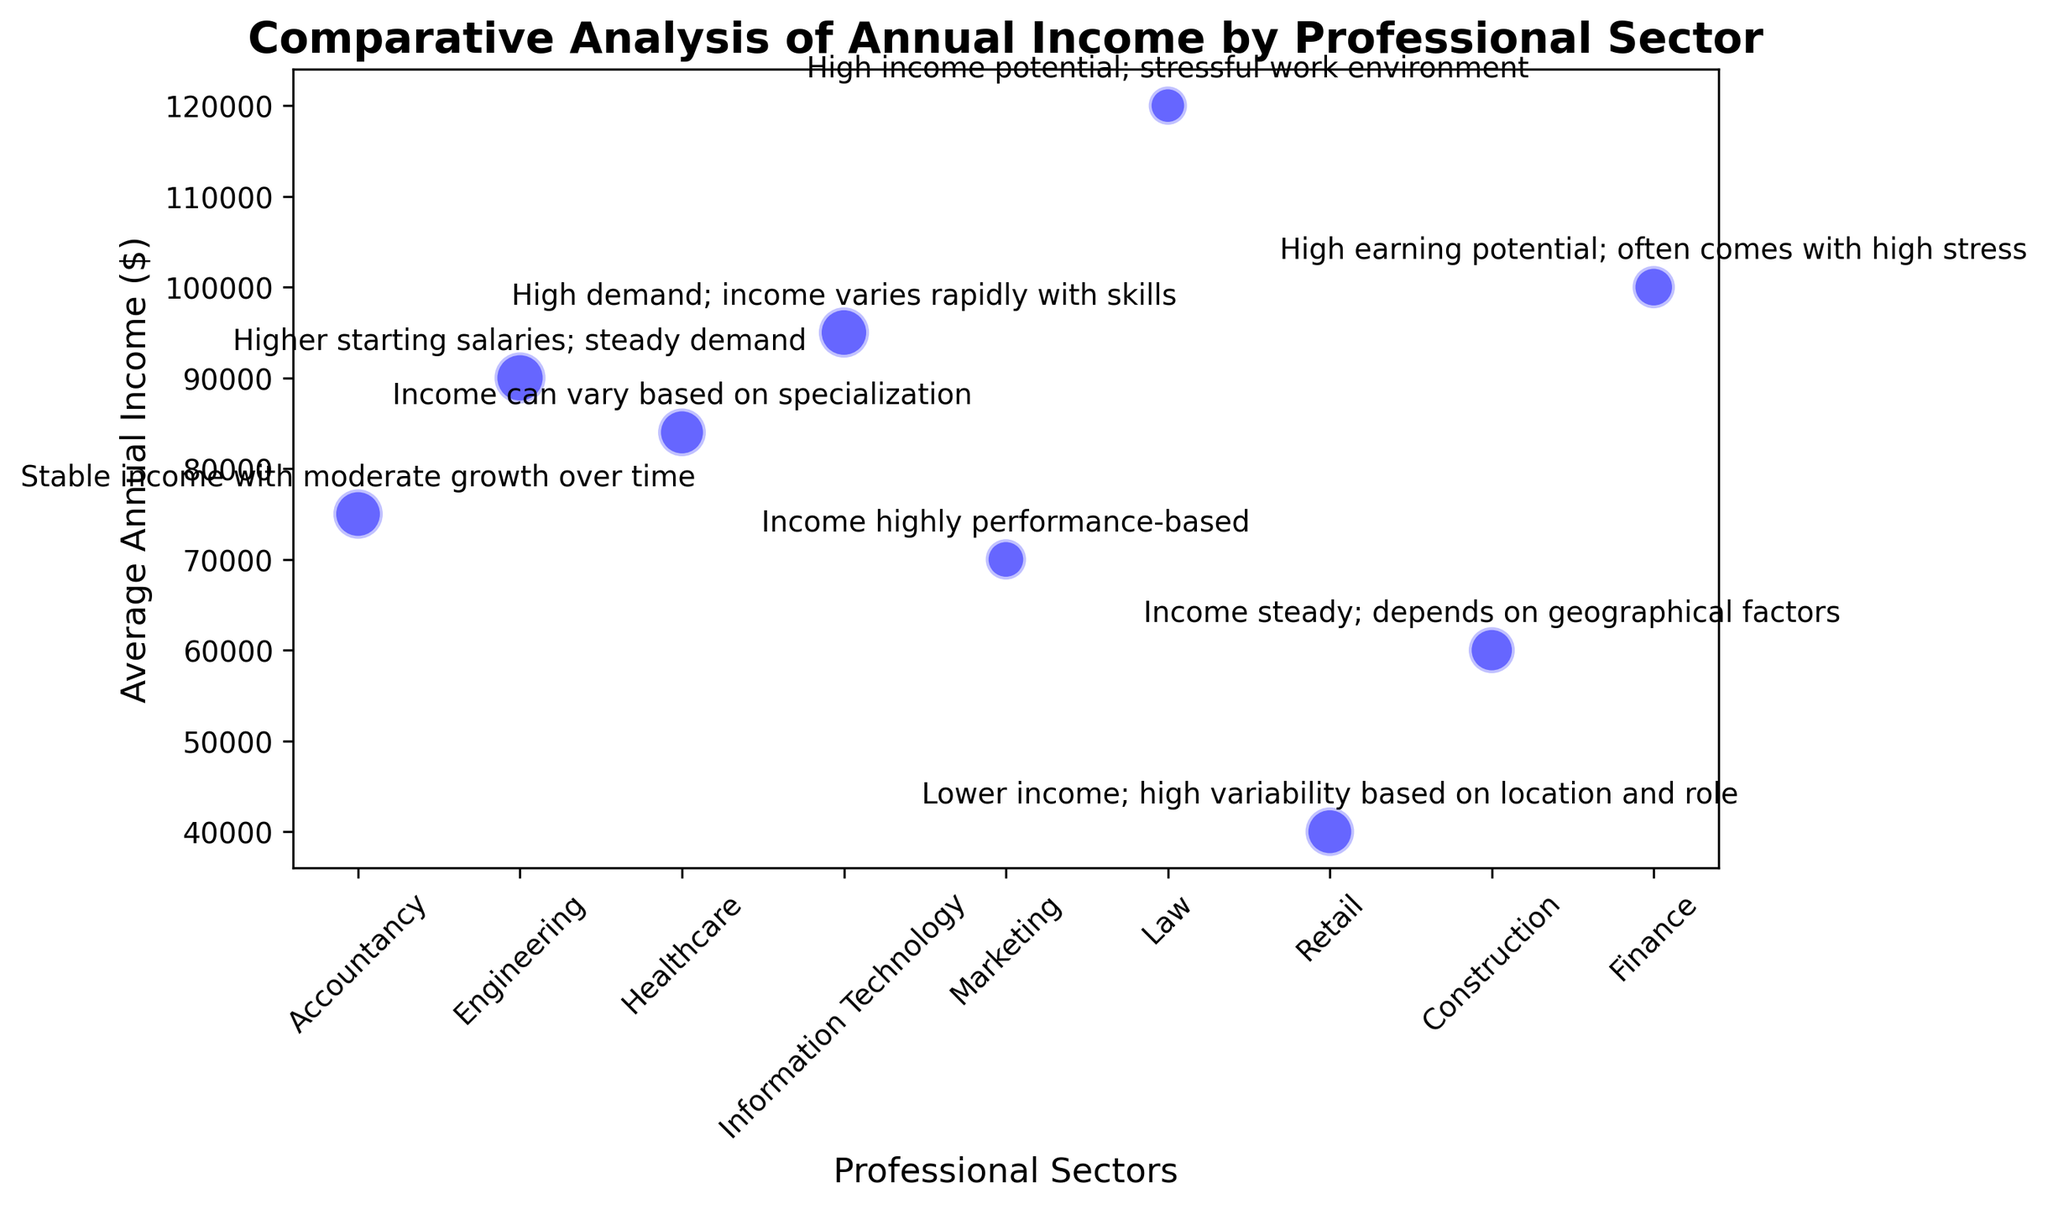Which professional sector has the highest average annual income? The dots on the plot show the average annual income for each sector. The highest value is $120,000, which belongs to the Law sector.
Answer: Law Which sector has the highest sample size in the figure? The size of the dots indicates the sample size. The Accountancy sector has the largest dot, indicating the highest sample size at 300.
Answer: Accountancy What is the difference in average annual income between Information Technology and Marketing? The average annual income for Information Technology is $95,000, and for Marketing it is $70,000. The difference is calculated as $95,000 - $70,000 = $25,000.
Answer: $25,000 Which sector has a higher average annual income: Healthcare or Construction? The plot shows Healthcare at $84,000 and Construction at $60,000. Comparatively, Healthcare has a higher average annual income.
Answer: Healthcare Comparing sample sizes, is the sample size for Finance greater than or equal to the sample size for Retail? The sample size for Finance is 220, and for Retail, it is 290. 220 is less than 290, so the sample size for Finance is not greater than or equal to Retail.
Answer: No What is the average annual income of sectors with more than 250 sample size? The sectors with more than 250 samples are Accountancy, Engineering, Information Technology, and Retail. Their incomes are $75,000, $90,000, $95,000, and $40,000 respectively. Average = (75,000 + 90,000 + 95,000 + 40,000)/4 = 300,000/4 = $75,000.
Answer: $75,000 Between Healthcare and Finance, which one has the higher income potential according to the comments? The Healthcare comment states "Income can vary based on specialization," while the Finance comment mentions "High earning potential; often comes with high stress." Comparatively, Finance is indicated to have a higher income potential.
Answer: Finance Which sector has the lowest average annual income and what is the sample size for this sector? The Retail sector has the lowest average annual income of $40,000. The sample size for Retail is 290.
Answer: Retail; 290 How many sectors have an average annual income of over $80,000? The sectors with average annual incomes over $80,000 are Engineering ($90,000), Healthcare ($84,000), Information Technology ($95,000), Law ($120,000), and Finance ($100,000). There are 5 such sectors.
Answer: 5 What is the combined average annual income of Accountancy, Marketing, and Construction sectors? The average incomes are $75,000 for Accountancy, $70,000 for Marketing, and $60,000 for Construction. Combined: $75,000 + $70,000 + $60,000 = $205,000.
Answer: $205,000 